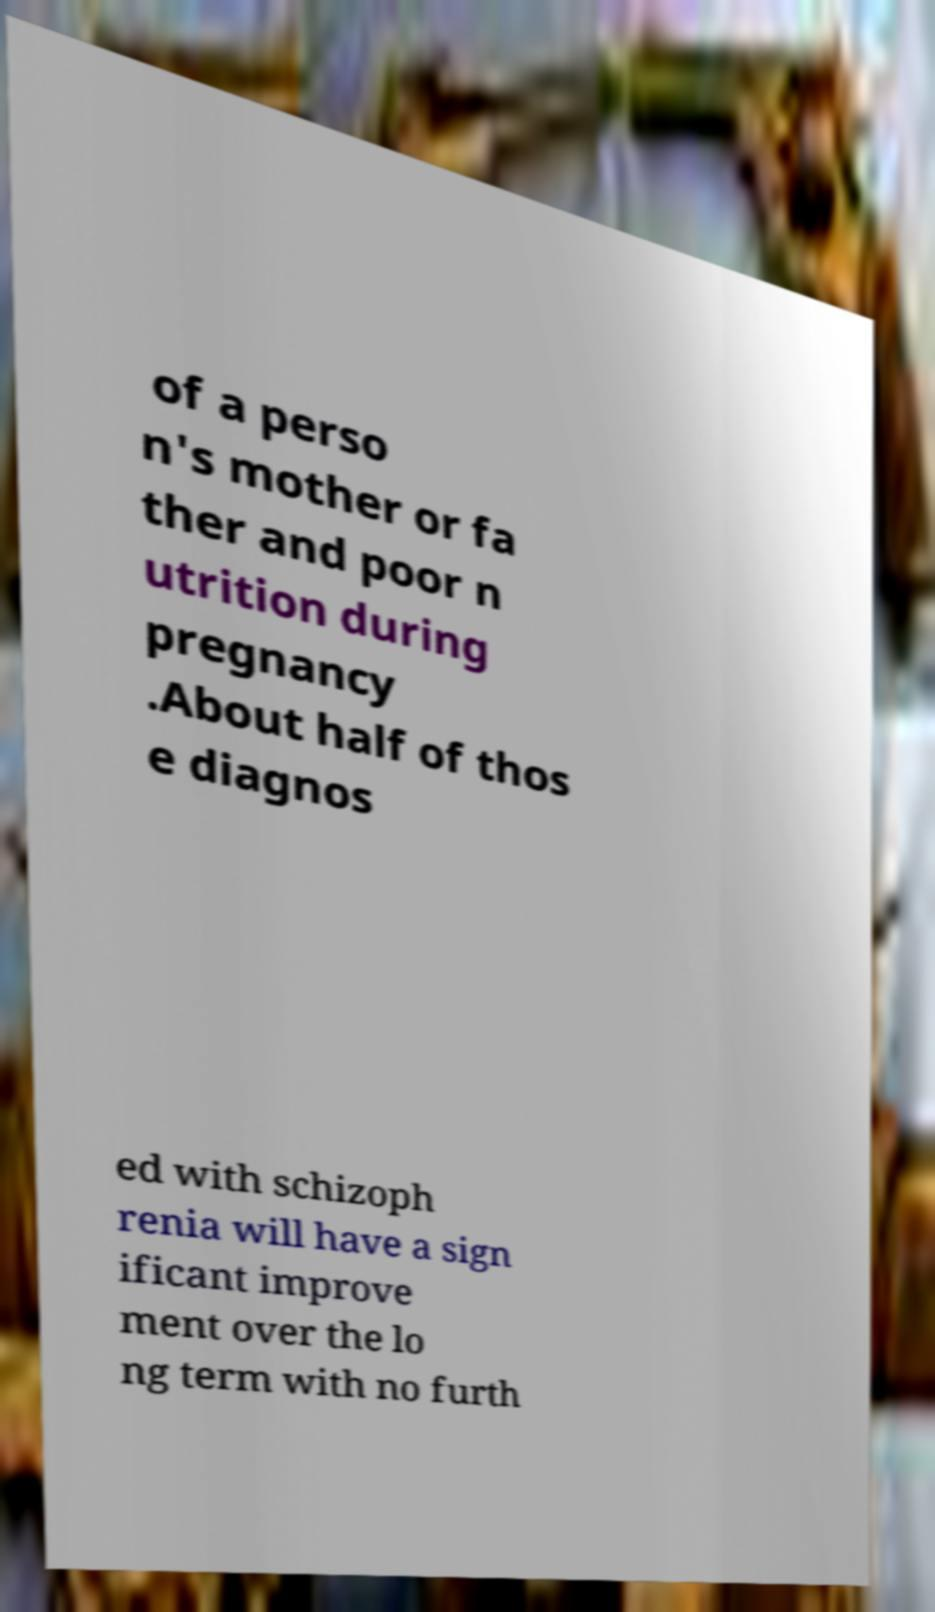Please identify and transcribe the text found in this image. of a perso n's mother or fa ther and poor n utrition during pregnancy .About half of thos e diagnos ed with schizoph renia will have a sign ificant improve ment over the lo ng term with no furth 